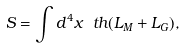<formula> <loc_0><loc_0><loc_500><loc_500>S = \int d ^ { 4 } x \ t h ( L _ { M } + L _ { G } ) ,</formula> 